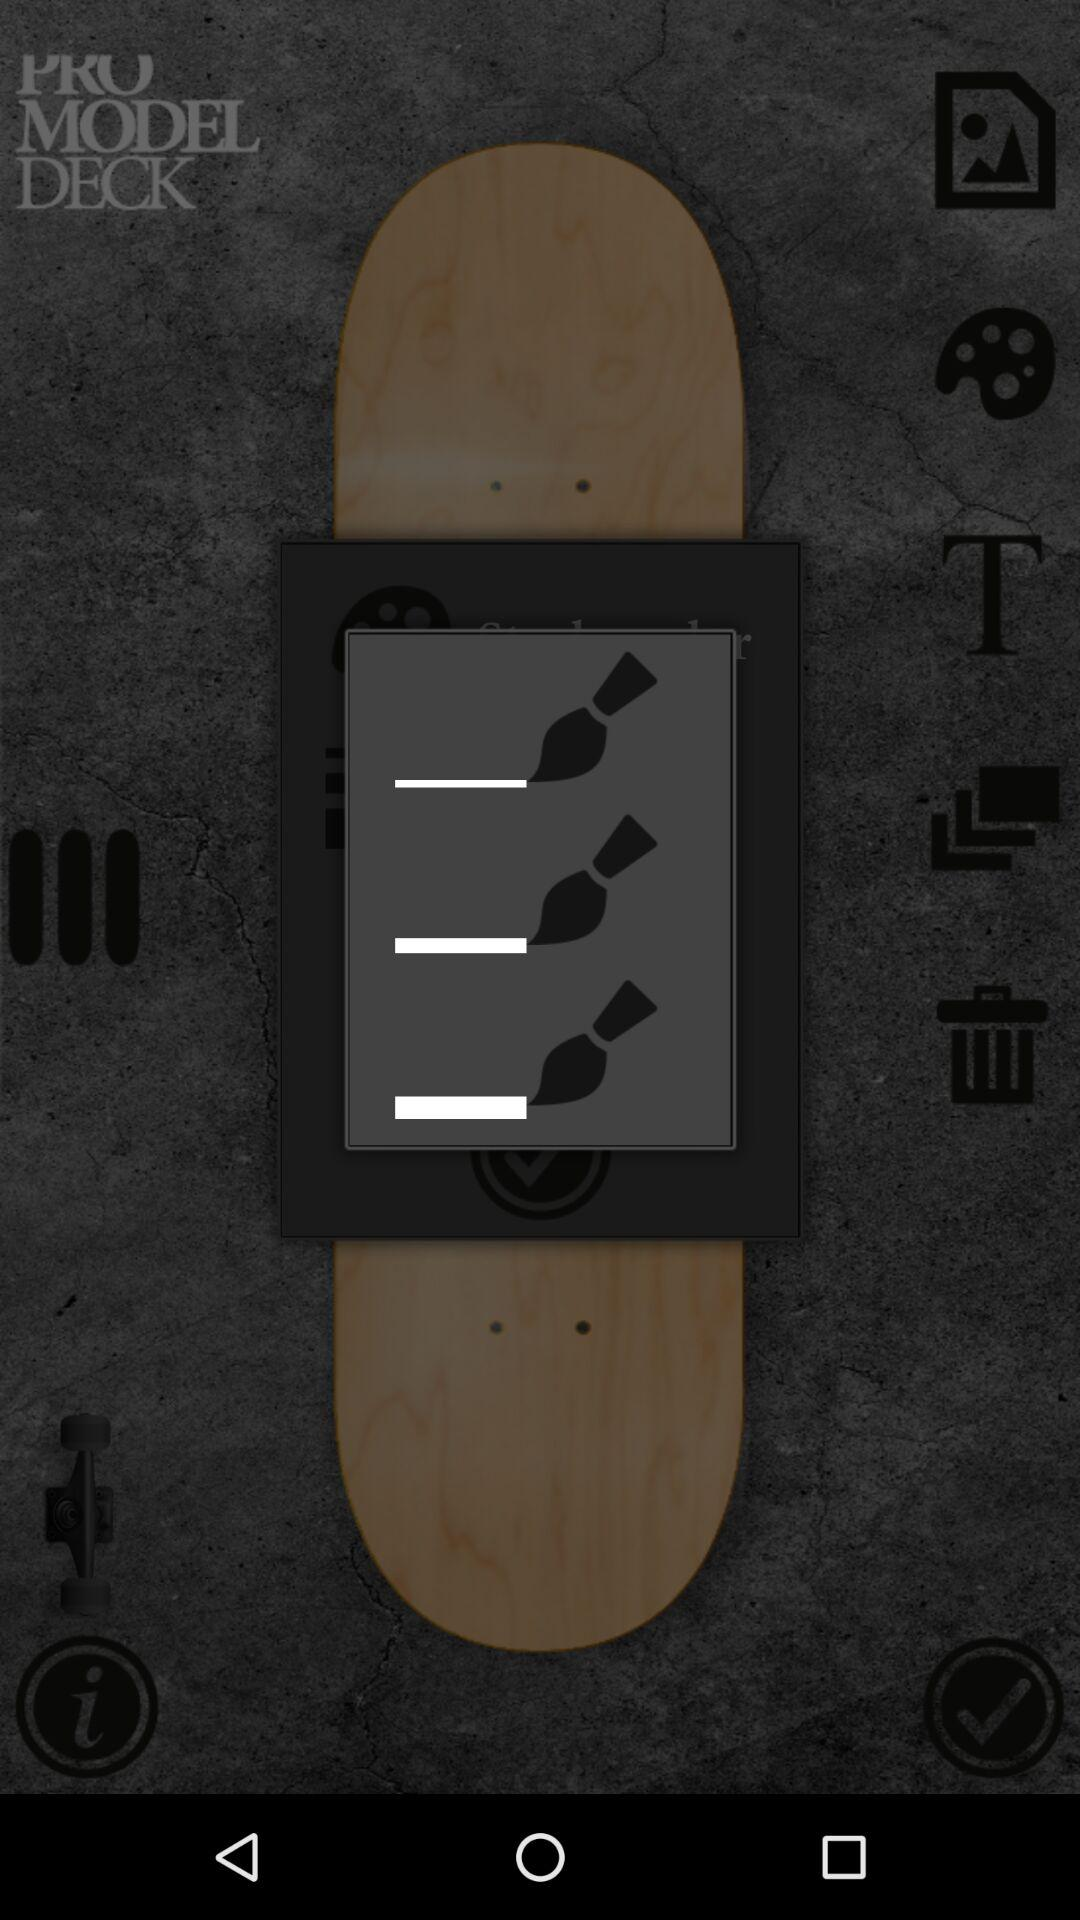What is the name of the application?
When the provided information is insufficient, respond with <no answer>. <no answer> 